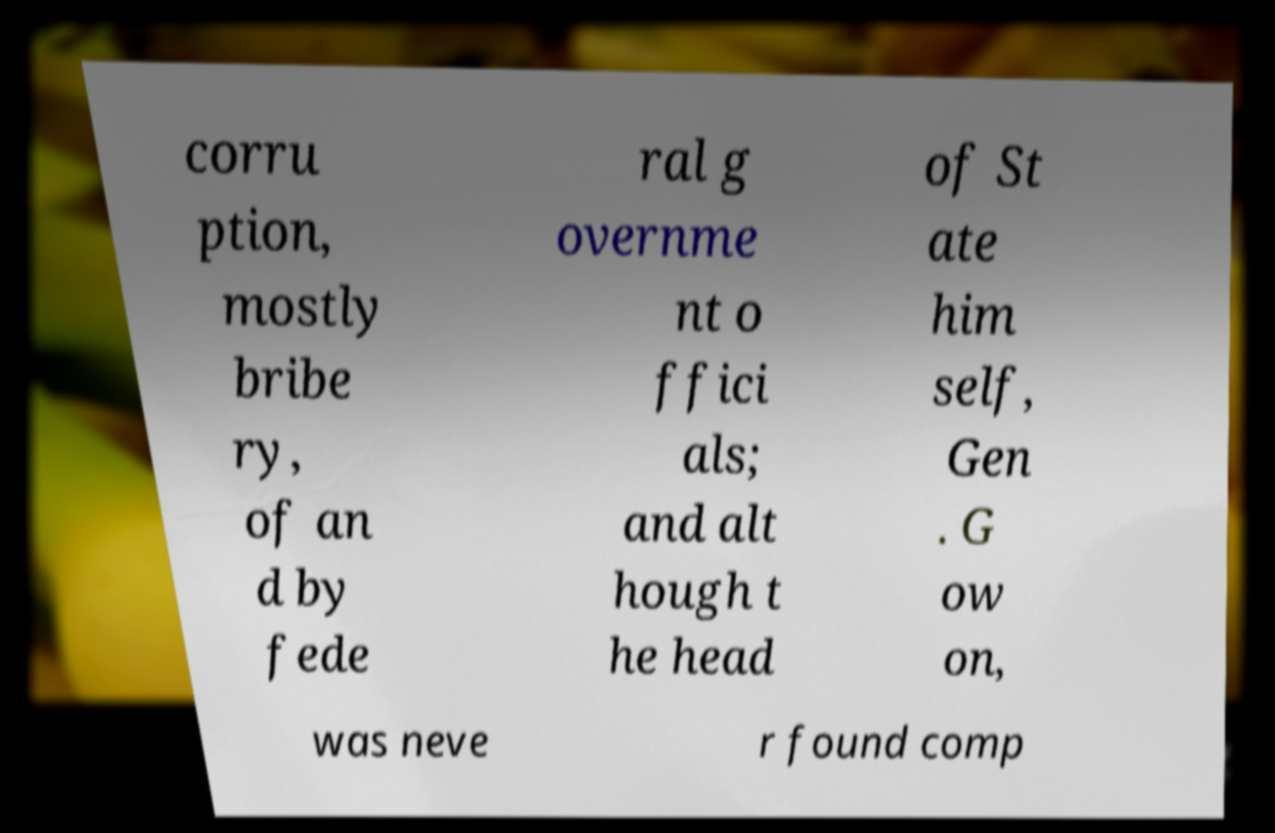For documentation purposes, I need the text within this image transcribed. Could you provide that? corru ption, mostly bribe ry, of an d by fede ral g overnme nt o ffici als; and alt hough t he head of St ate him self, Gen . G ow on, was neve r found comp 